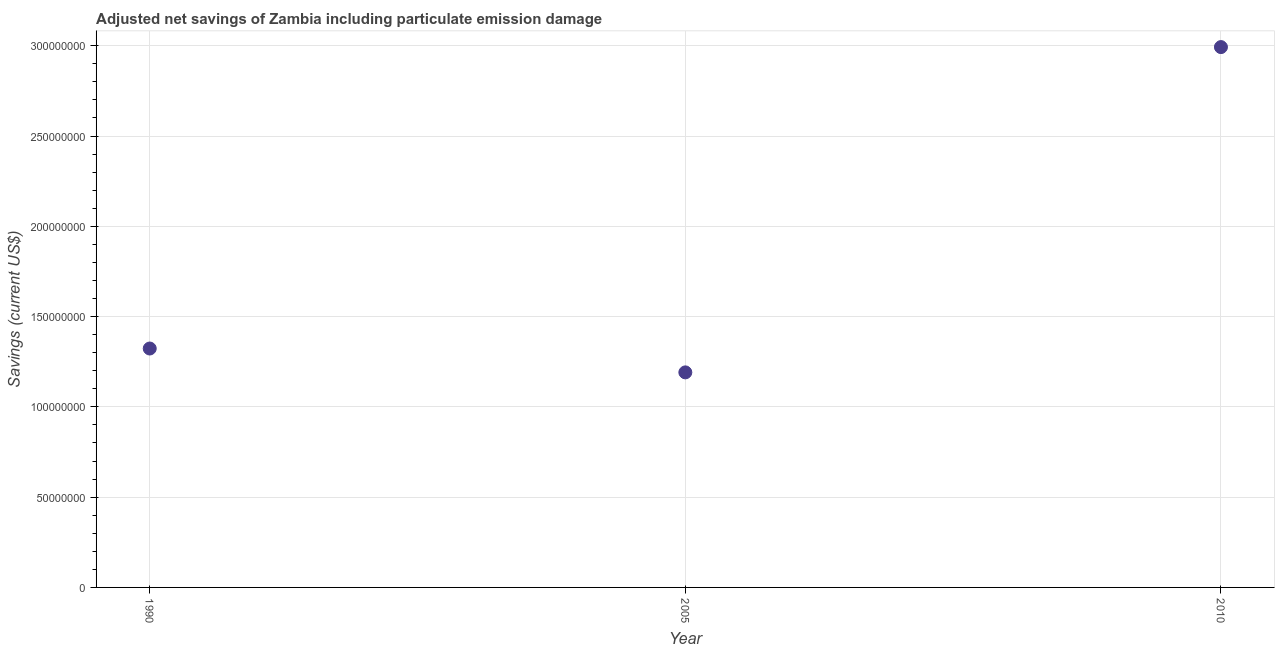What is the adjusted net savings in 2010?
Your response must be concise. 2.99e+08. Across all years, what is the maximum adjusted net savings?
Ensure brevity in your answer.  2.99e+08. Across all years, what is the minimum adjusted net savings?
Your answer should be compact. 1.19e+08. In which year was the adjusted net savings minimum?
Offer a very short reply. 2005. What is the sum of the adjusted net savings?
Make the answer very short. 5.51e+08. What is the difference between the adjusted net savings in 1990 and 2005?
Provide a short and direct response. 1.32e+07. What is the average adjusted net savings per year?
Provide a succinct answer. 1.84e+08. What is the median adjusted net savings?
Your answer should be compact. 1.32e+08. In how many years, is the adjusted net savings greater than 160000000 US$?
Your answer should be very brief. 1. Do a majority of the years between 1990 and 2005 (inclusive) have adjusted net savings greater than 170000000 US$?
Your answer should be compact. No. What is the ratio of the adjusted net savings in 2005 to that in 2010?
Your answer should be compact. 0.4. Is the adjusted net savings in 1990 less than that in 2005?
Your response must be concise. No. What is the difference between the highest and the second highest adjusted net savings?
Your answer should be compact. 1.67e+08. What is the difference between the highest and the lowest adjusted net savings?
Your answer should be compact. 1.80e+08. Are the values on the major ticks of Y-axis written in scientific E-notation?
Offer a very short reply. No. Does the graph contain any zero values?
Keep it short and to the point. No. Does the graph contain grids?
Provide a short and direct response. Yes. What is the title of the graph?
Your answer should be compact. Adjusted net savings of Zambia including particulate emission damage. What is the label or title of the Y-axis?
Offer a very short reply. Savings (current US$). What is the Savings (current US$) in 1990?
Provide a short and direct response. 1.32e+08. What is the Savings (current US$) in 2005?
Make the answer very short. 1.19e+08. What is the Savings (current US$) in 2010?
Give a very brief answer. 2.99e+08. What is the difference between the Savings (current US$) in 1990 and 2005?
Your response must be concise. 1.32e+07. What is the difference between the Savings (current US$) in 1990 and 2010?
Your answer should be compact. -1.67e+08. What is the difference between the Savings (current US$) in 2005 and 2010?
Offer a very short reply. -1.80e+08. What is the ratio of the Savings (current US$) in 1990 to that in 2005?
Provide a short and direct response. 1.11. What is the ratio of the Savings (current US$) in 1990 to that in 2010?
Your answer should be compact. 0.44. What is the ratio of the Savings (current US$) in 2005 to that in 2010?
Provide a succinct answer. 0.4. 